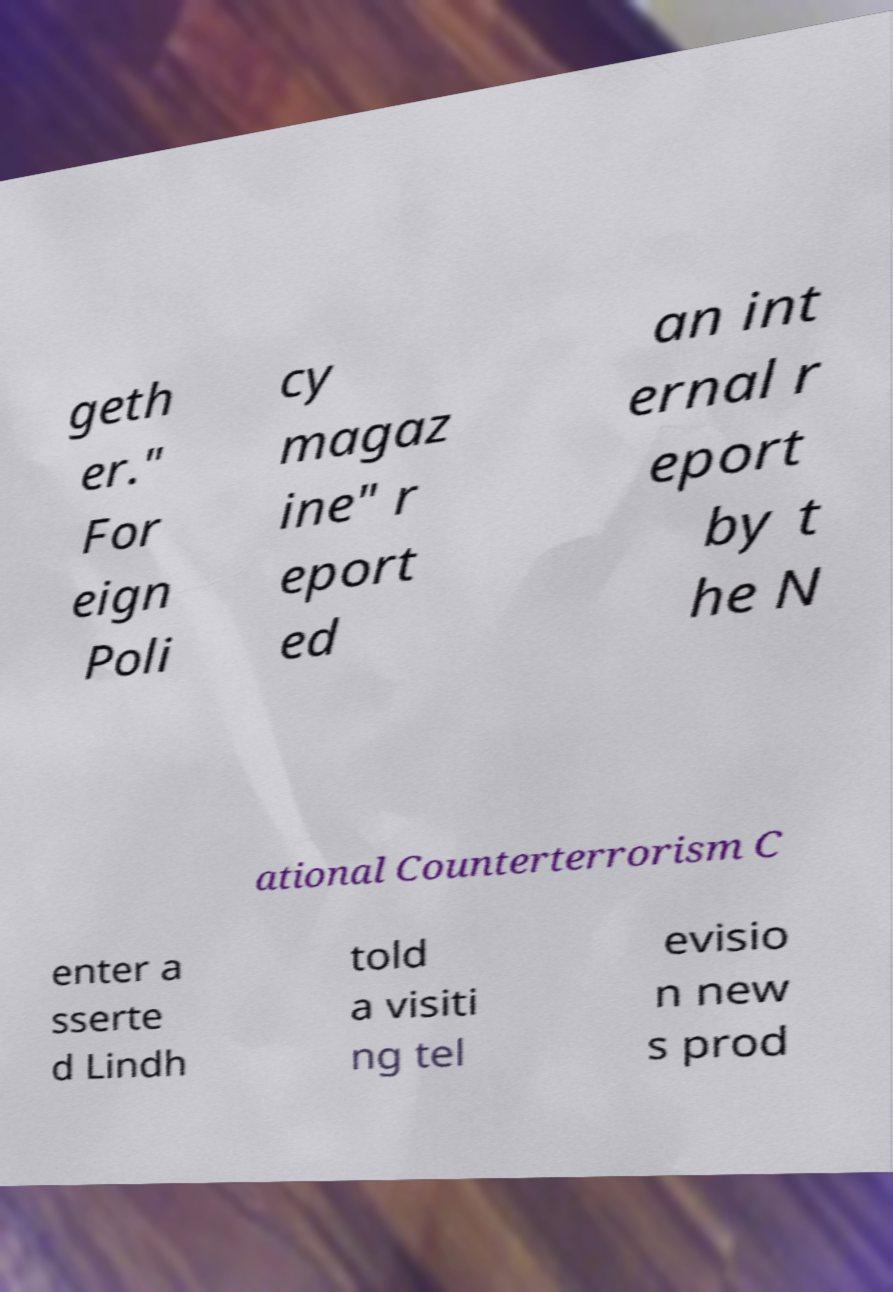I need the written content from this picture converted into text. Can you do that? geth er." For eign Poli cy magaz ine" r eport ed an int ernal r eport by t he N ational Counterterrorism C enter a sserte d Lindh told a visiti ng tel evisio n new s prod 